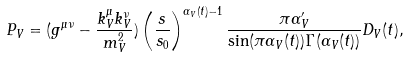Convert formula to latex. <formula><loc_0><loc_0><loc_500><loc_500>P _ { V } = ( g ^ { \mu \nu } - \frac { k _ { V } ^ { \mu } k _ { V } ^ { \nu } } { m _ { V } ^ { 2 } } ) \left ( \frac { s } { s _ { 0 } } \right ) ^ { \alpha _ { V } ( t ) - 1 } \frac { \pi \alpha _ { V } ^ { \prime } } { \sin ( \pi \alpha _ { V } ( t ) ) \Gamma ( \alpha _ { V } ( t ) ) } D _ { V } ( t ) ,</formula> 